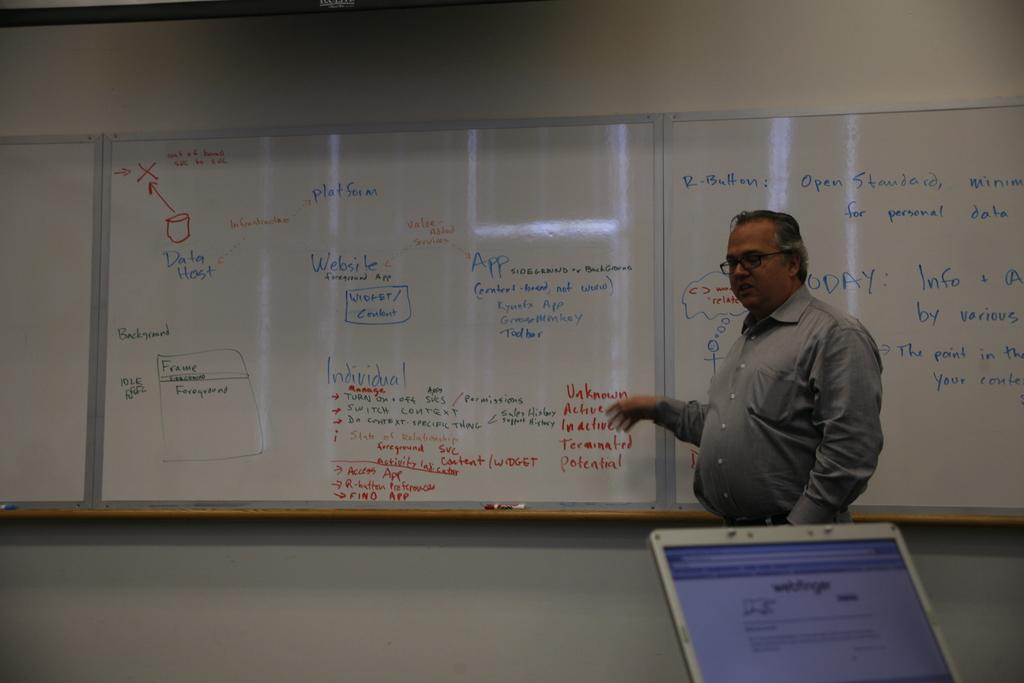<image>
Render a clear and concise summary of the photo. Lecture with notes about websites and apps on the whiteboard. 